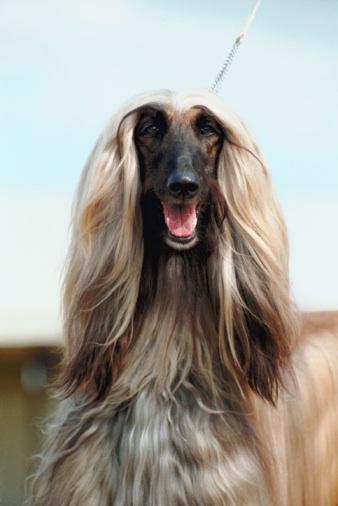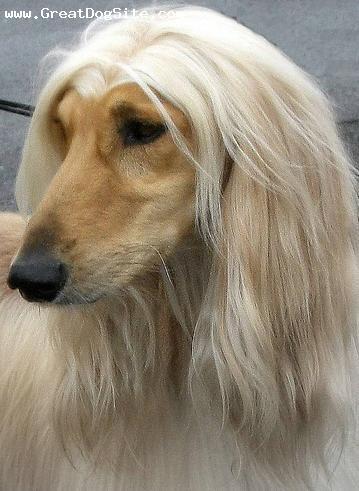The first image is the image on the left, the second image is the image on the right. Evaluate the accuracy of this statement regarding the images: "An image shows a reclining hound with its front paws extended in front of its body.". Is it true? Answer yes or no. No. The first image is the image on the left, the second image is the image on the right. Assess this claim about the two images: "The legs of the Afphan dog are not visible in at least one of the images.". Correct or not? Answer yes or no. Yes. 